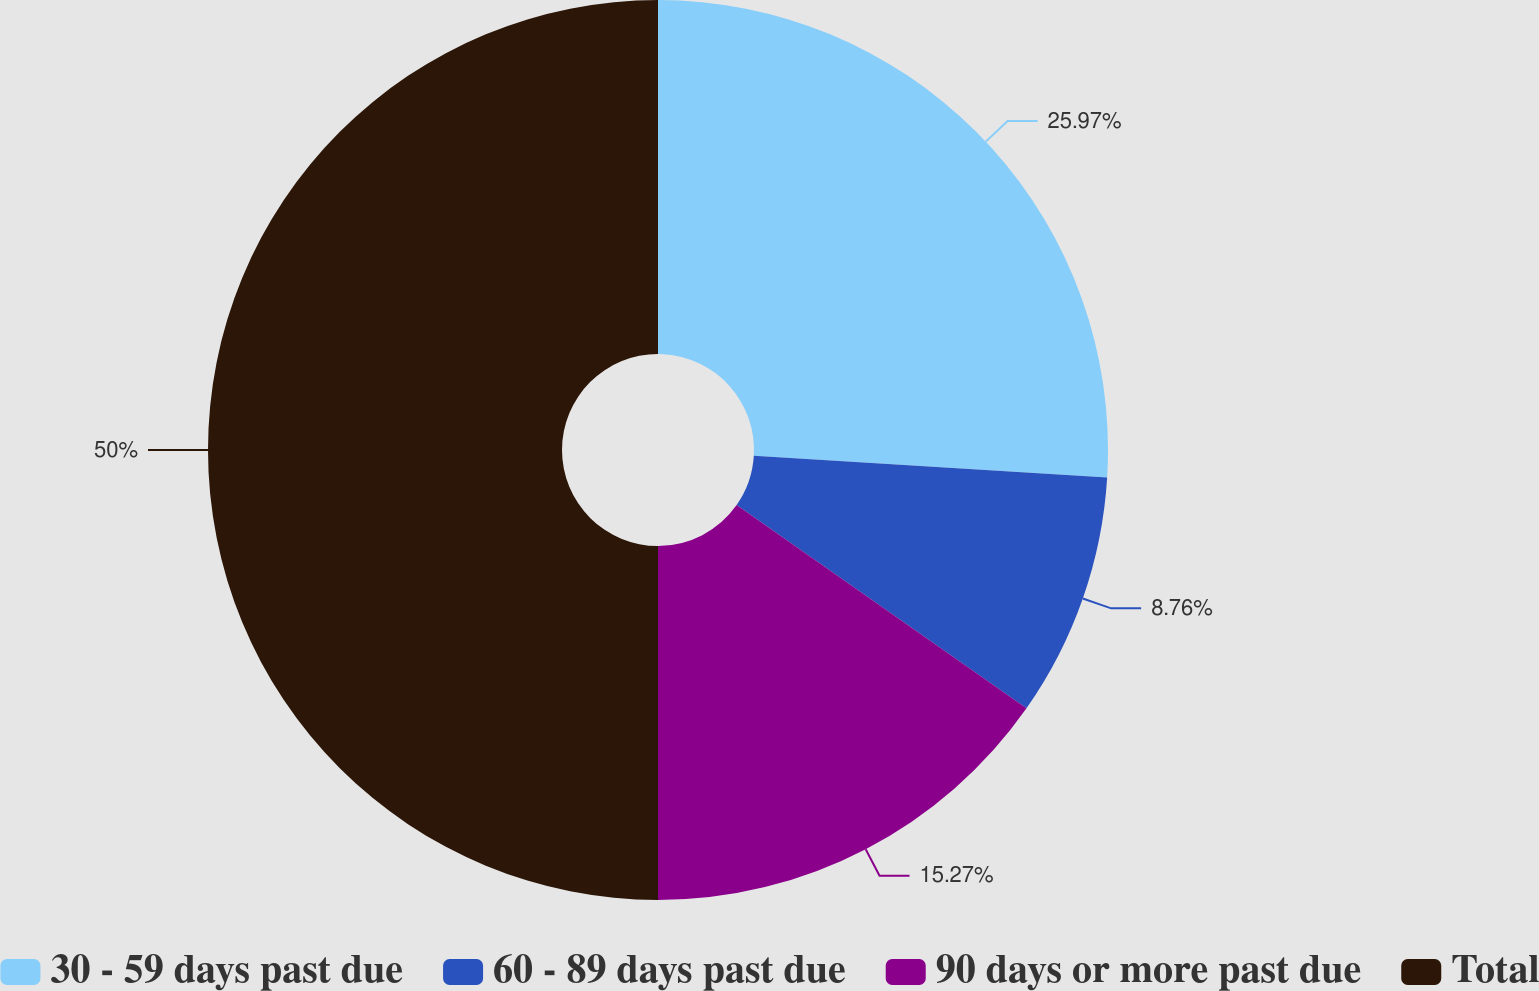Convert chart. <chart><loc_0><loc_0><loc_500><loc_500><pie_chart><fcel>30 - 59 days past due<fcel>60 - 89 days past due<fcel>90 days or more past due<fcel>Total<nl><fcel>25.97%<fcel>8.76%<fcel>15.27%<fcel>50.0%<nl></chart> 